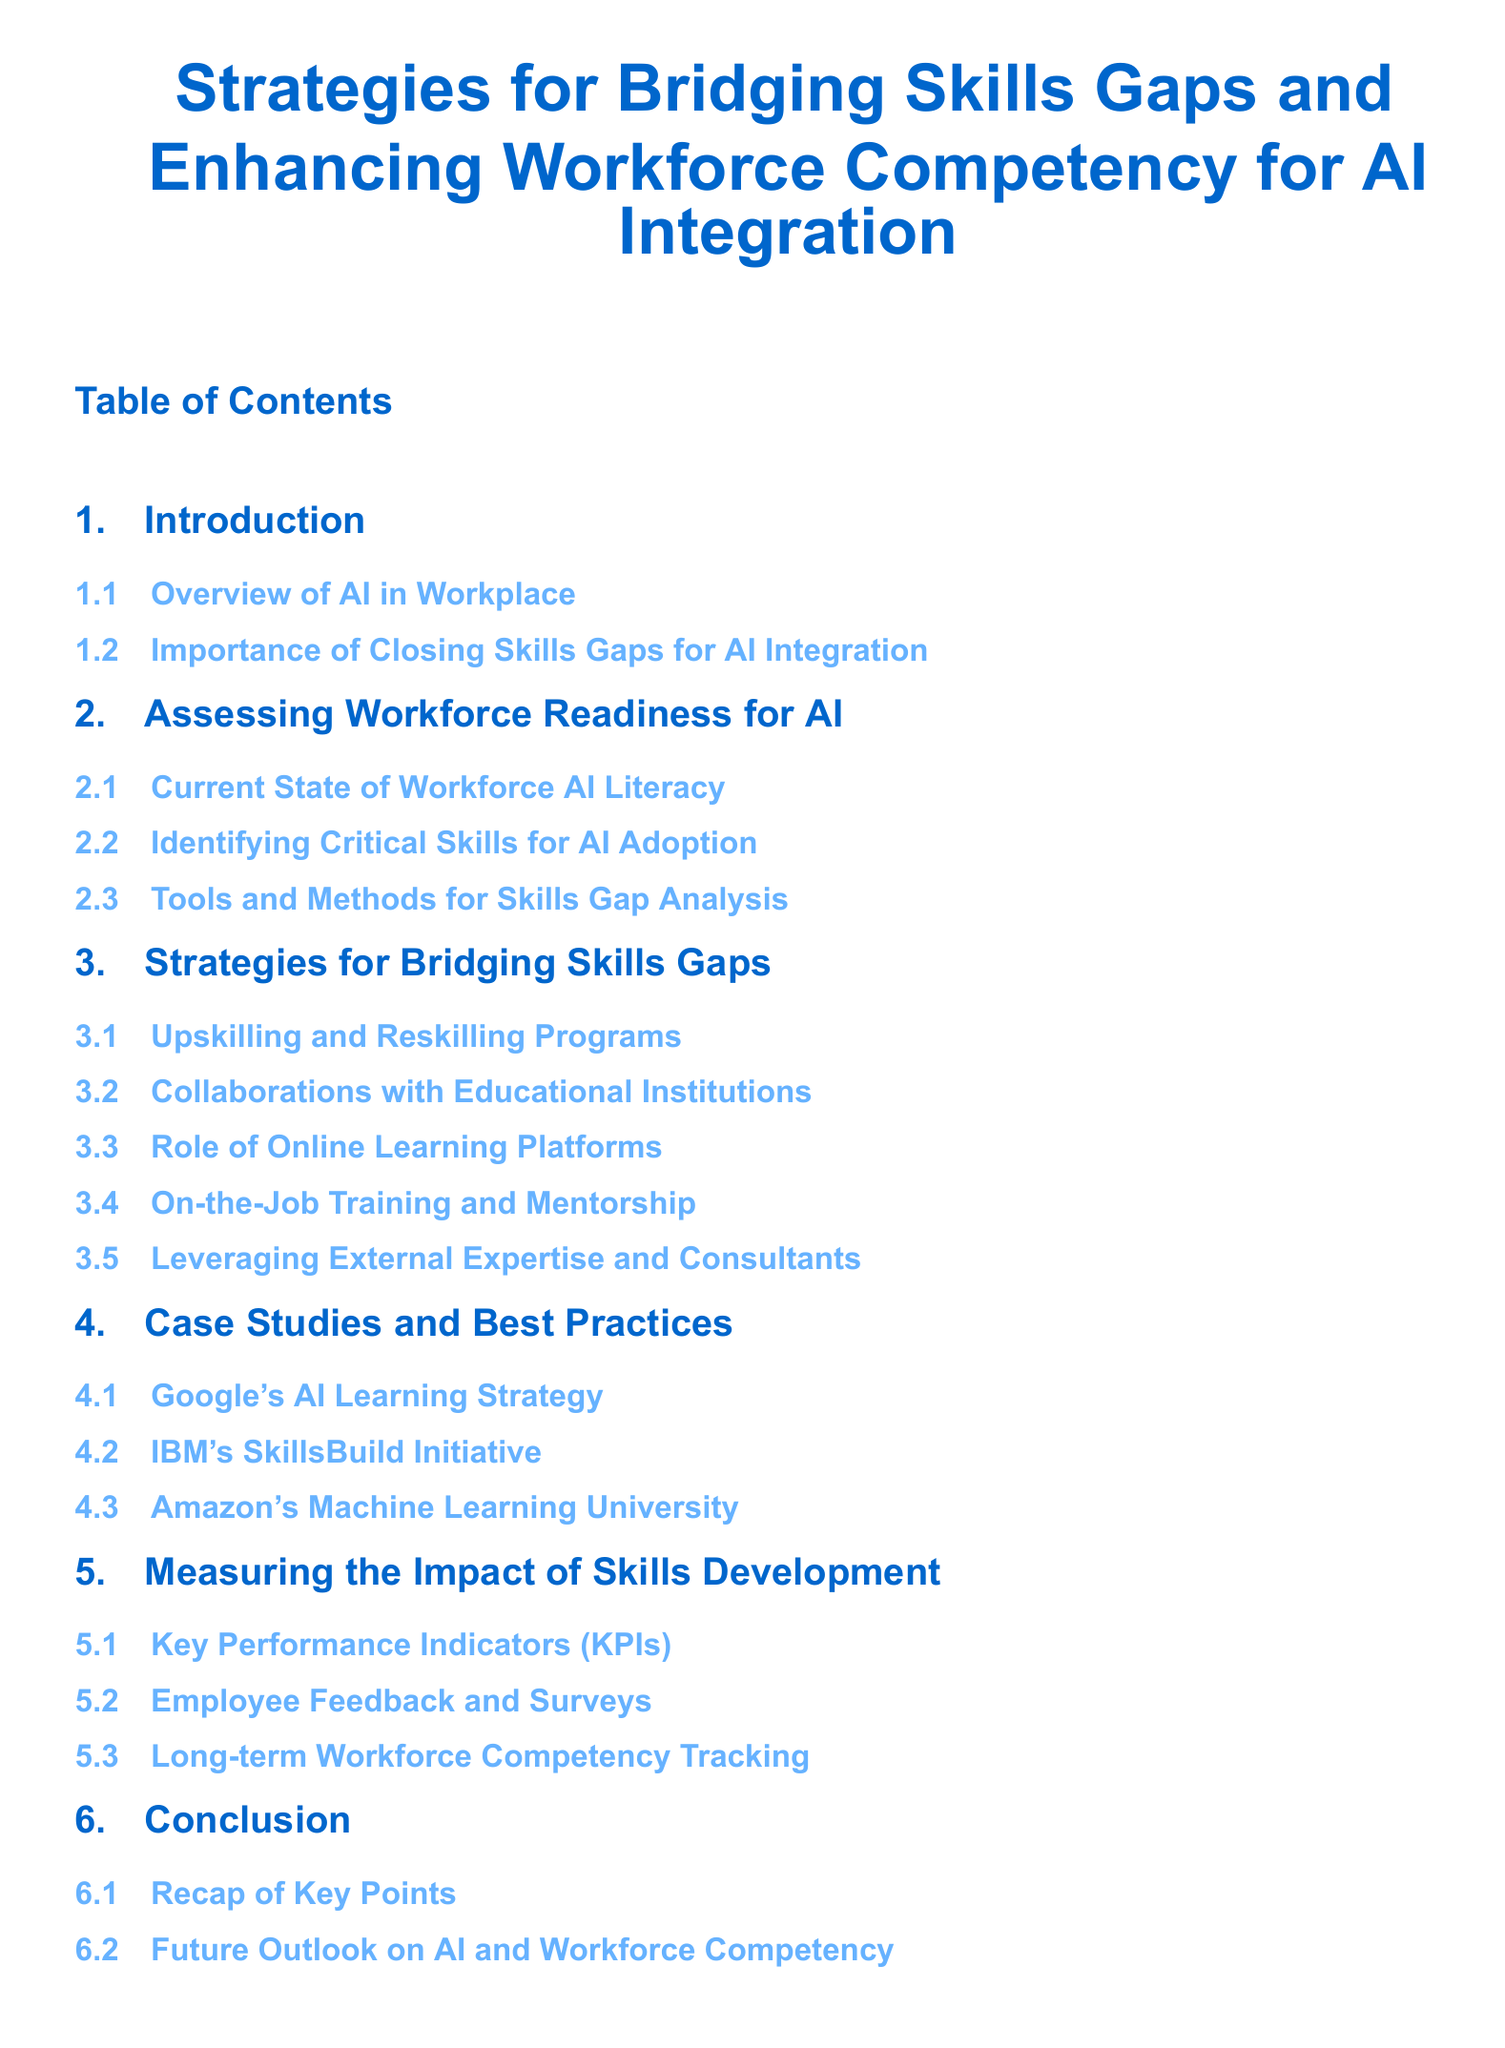What is the title of the document? The title of the document is the main heading presented in the center, which summarizes the document's content.
Answer: Strategies for Bridging Skills Gaps and Enhancing Workforce Competency for AI Integration What section discusses the current state of workforce AI literacy? This section title clearly indicates that it addresses how prepared the workforce is in relation to AI knowledge and skills.
Answer: Current State of Workforce AI Literacy How many subsections are in the Strategies for Bridging Skills Gaps section? By counting the listed subsections under the specified section, the total can be determined.
Answer: Five What is one method for skills gap analysis mentioned in the document? This is sought from the titles of the subsections under the relevant section, as it reveals specific strategies or methods discussed.
Answer: Tools and Methods for Skills Gap Analysis Which company's AI learning strategy is featured as a case study? This question pertains to one of the examples provided in the case studies section, specifically the title of the company being focused on.
Answer: Google's AI Learning Strategy What is the importance of closing skills gaps for AI integration? This section title captures the main concept regarding why addressing skills gaps is necessary for effective AI implementation in the workforce.
Answer: Importance of Closing Skills Gaps for AI Integration What does the conclusion recap? The conclusion section is segmented to summarize key findings, which can be extracted from its title.
Answer: Recap of Key Points 